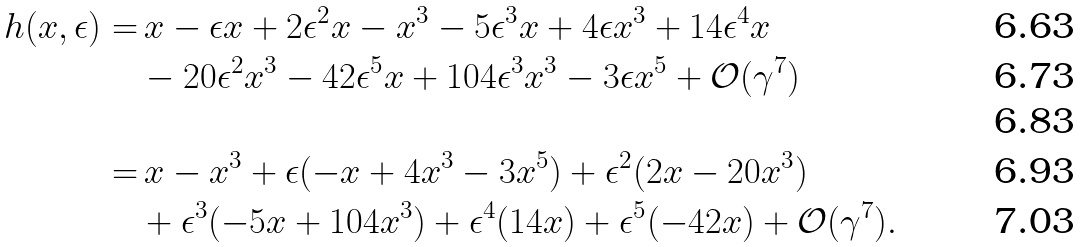Convert formula to latex. <formula><loc_0><loc_0><loc_500><loc_500>h ( x , \epsilon ) = & \, x - \epsilon x + 2 \epsilon ^ { 2 } x - x ^ { 3 } - 5 \epsilon ^ { 3 } x + 4 \epsilon x ^ { 3 } + 1 4 \epsilon ^ { 4 } x \\ & - 2 0 \epsilon ^ { 2 } x ^ { 3 } - 4 2 \epsilon ^ { 5 } x + 1 0 4 \epsilon ^ { 3 } x ^ { 3 } - 3 \epsilon x ^ { 5 } + \mathcal { O } ( \gamma ^ { 7 } ) \\ \\ = & \, x - x ^ { 3 } + \epsilon ( - x + 4 x ^ { 3 } - 3 x ^ { 5 } ) + \epsilon ^ { 2 } ( 2 x - 2 0 x ^ { 3 } ) \\ & + \epsilon ^ { 3 } ( - 5 x + 1 0 4 x ^ { 3 } ) + \epsilon ^ { 4 } ( 1 4 x ) + \epsilon ^ { 5 } ( - 4 2 x ) + \mathcal { O } ( \gamma ^ { 7 } ) .</formula> 